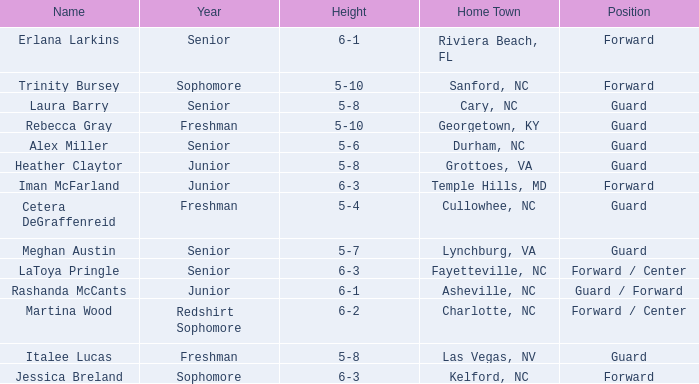In what year of school is the player from Fayetteville, NC? Senior. 